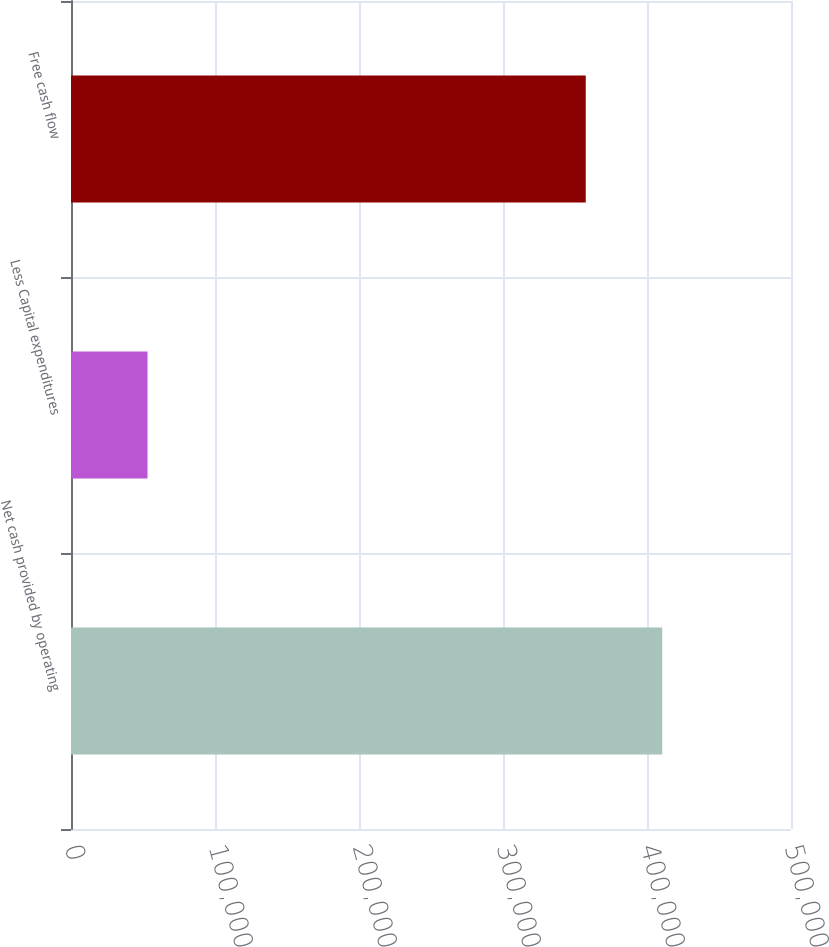<chart> <loc_0><loc_0><loc_500><loc_500><bar_chart><fcel>Net cash provided by operating<fcel>Less Capital expenditures<fcel>Free cash flow<nl><fcel>410590<fcel>53135<fcel>357455<nl></chart> 